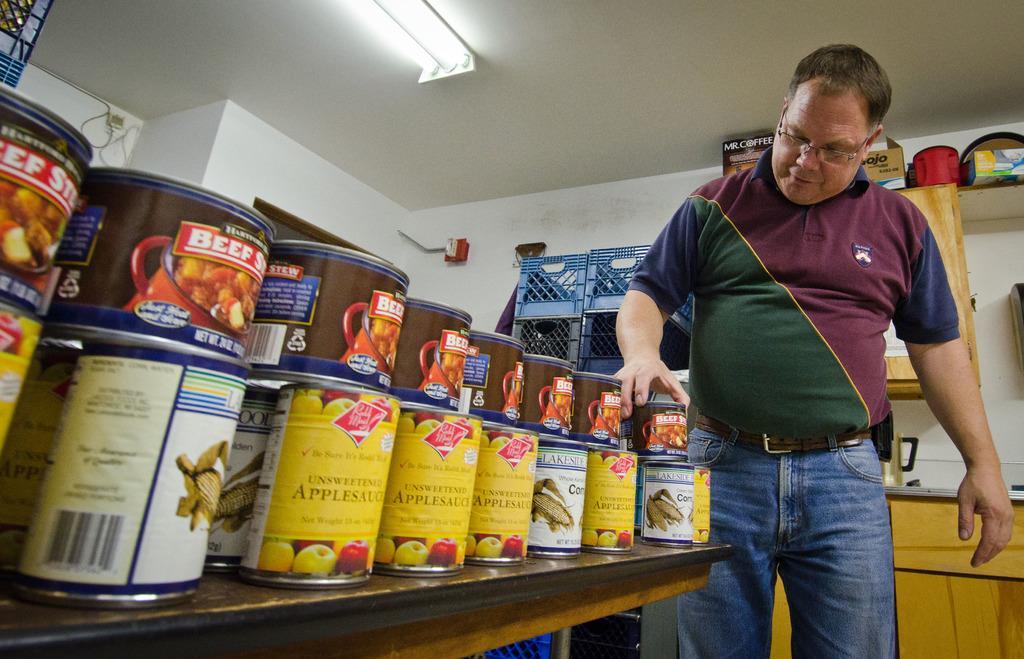Can you describe this image briefly? In this image there is person. There are boxes. There is a fan. There is a wall. 